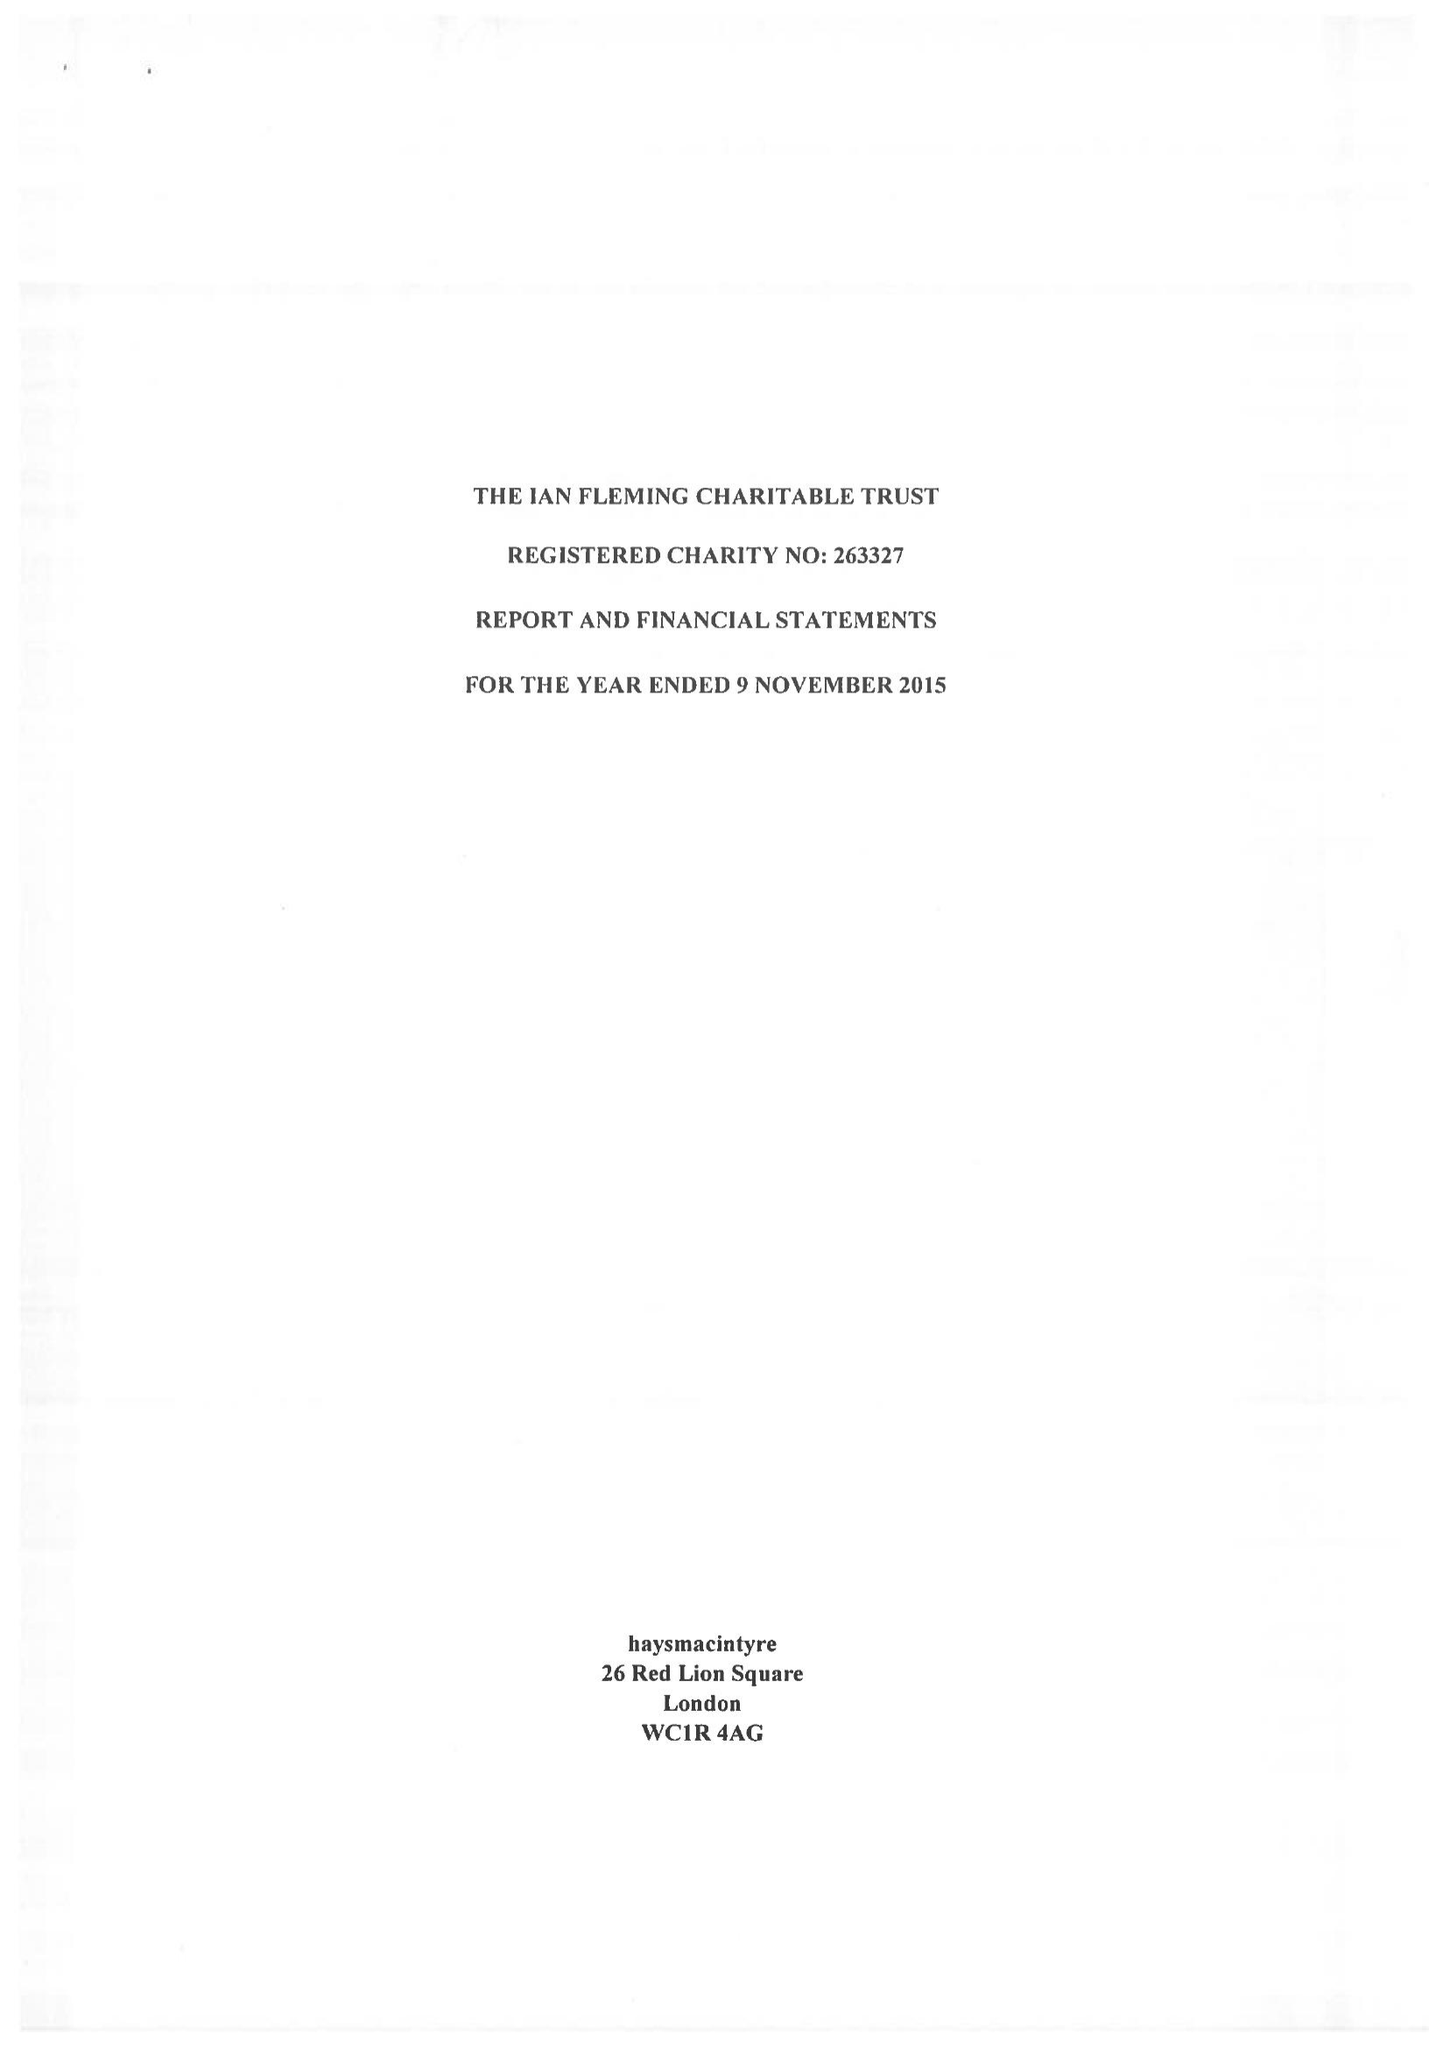What is the value for the address__postcode?
Answer the question using a single word or phrase. EC4R 1AG 